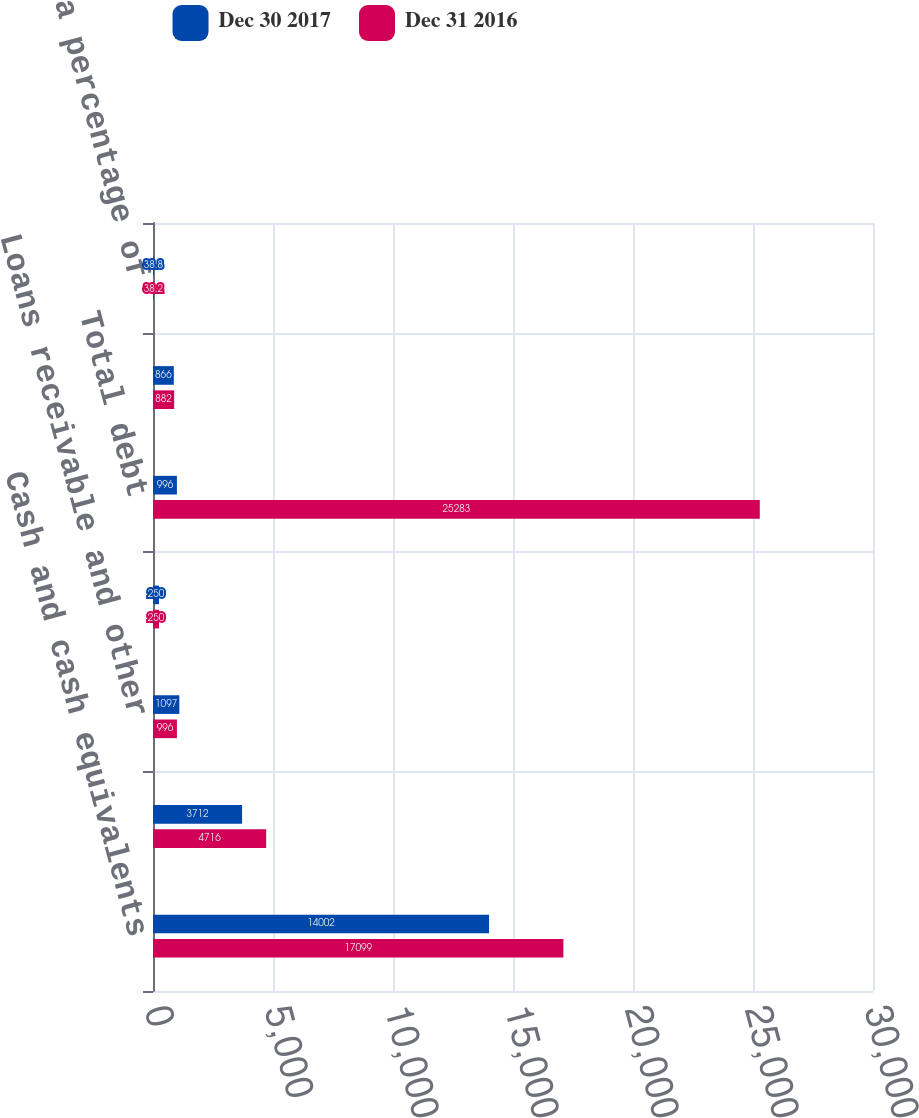Convert chart to OTSL. <chart><loc_0><loc_0><loc_500><loc_500><stacked_bar_chart><ecel><fcel>Cash and cash equivalents<fcel>Other long-term investments<fcel>Loans receivable and other<fcel>Reverse repurchase agreements<fcel>Total debt<fcel>Temporary equity<fcel>Debt as a percentage of<nl><fcel>Dec 30 2017<fcel>14002<fcel>3712<fcel>1097<fcel>250<fcel>996<fcel>866<fcel>38.8<nl><fcel>Dec 31 2016<fcel>17099<fcel>4716<fcel>996<fcel>250<fcel>25283<fcel>882<fcel>38.2<nl></chart> 